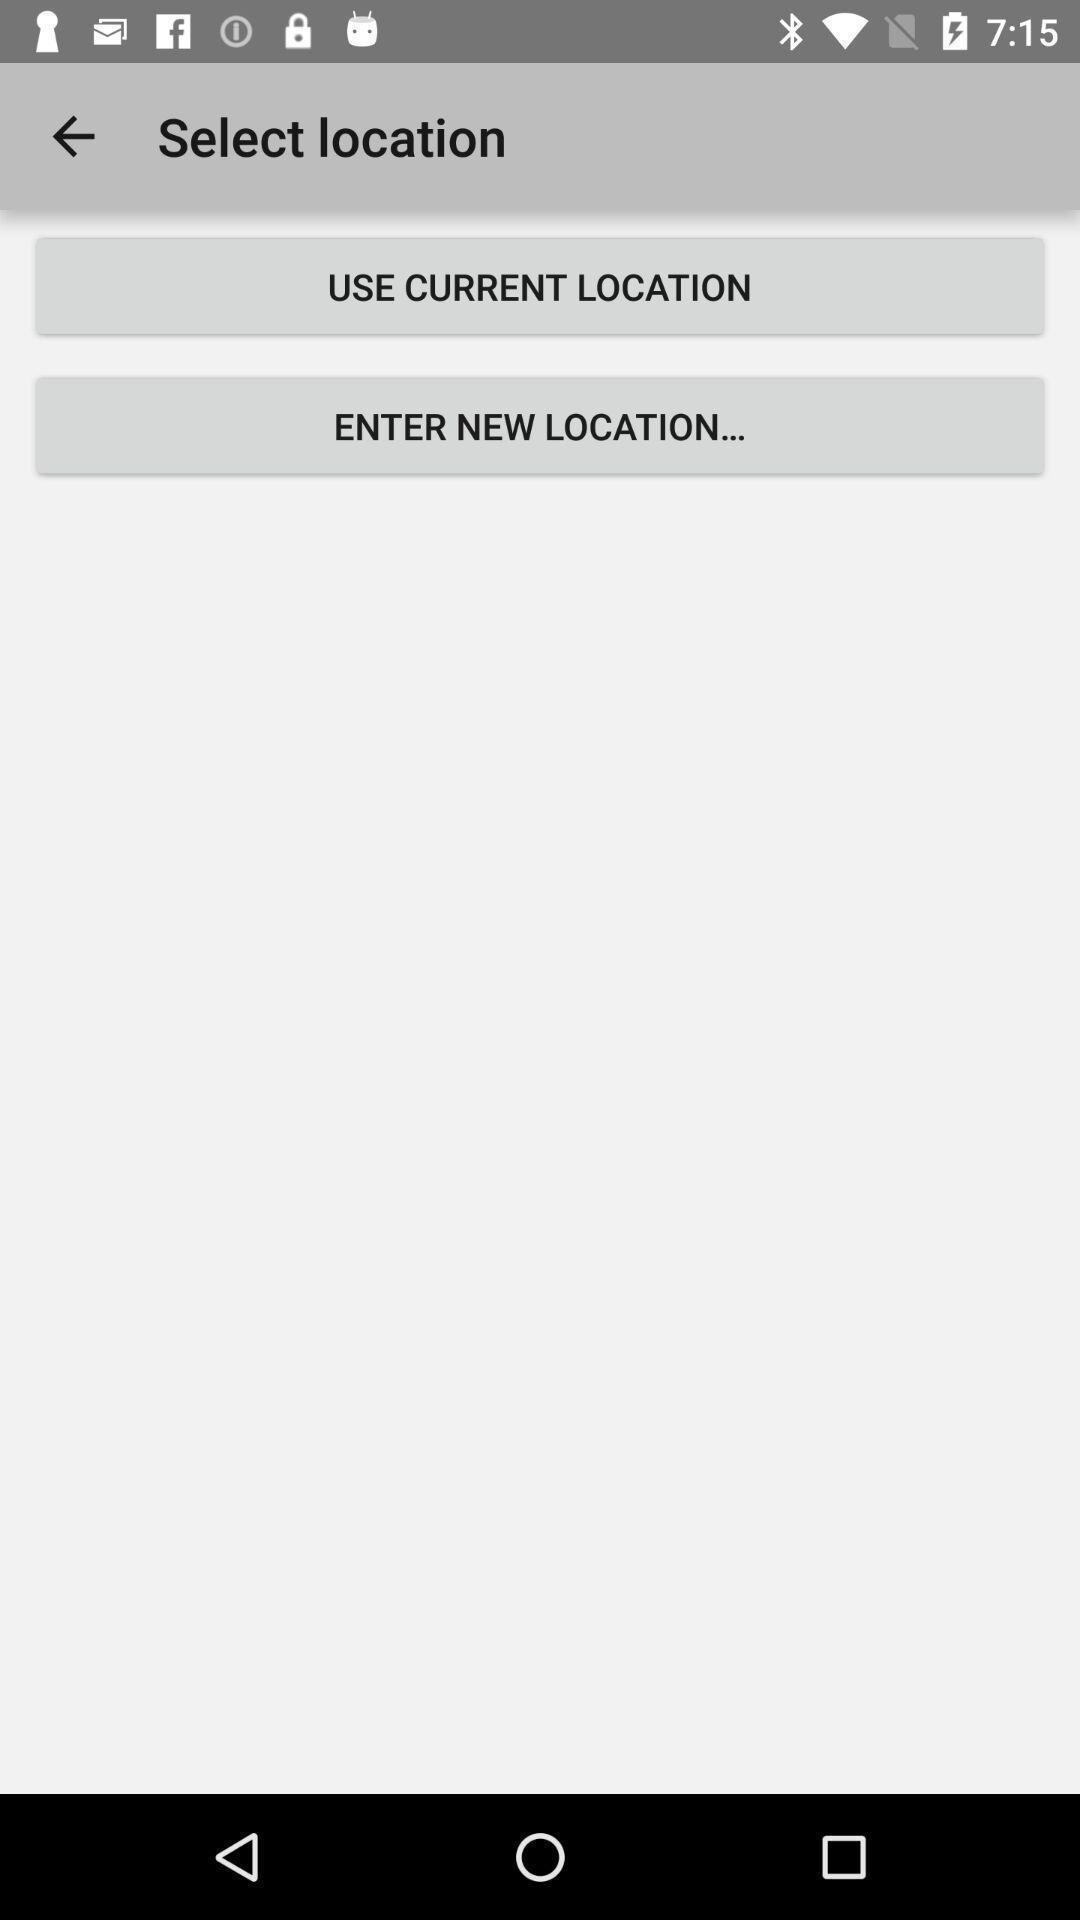Explain the elements present in this screenshot. Page showing variety of locations. 